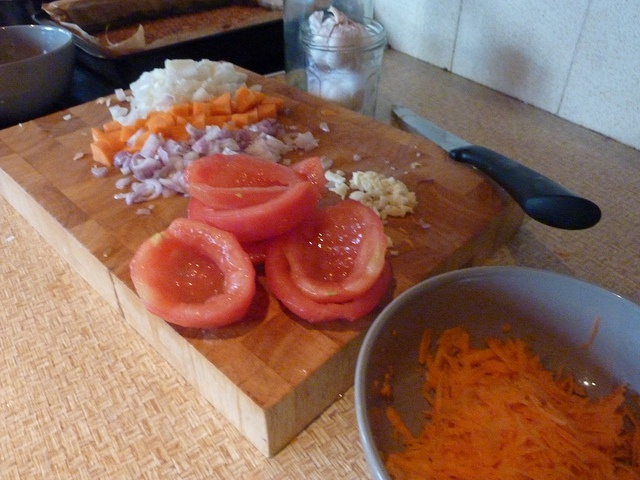Describe the objects in this image and their specific colors. I can see bowl in black, maroon, brown, and gray tones, carrot in black, maroon, and brown tones, cup in black, gray, and darkgray tones, bowl in black and gray tones, and knife in black, navy, and gray tones in this image. 